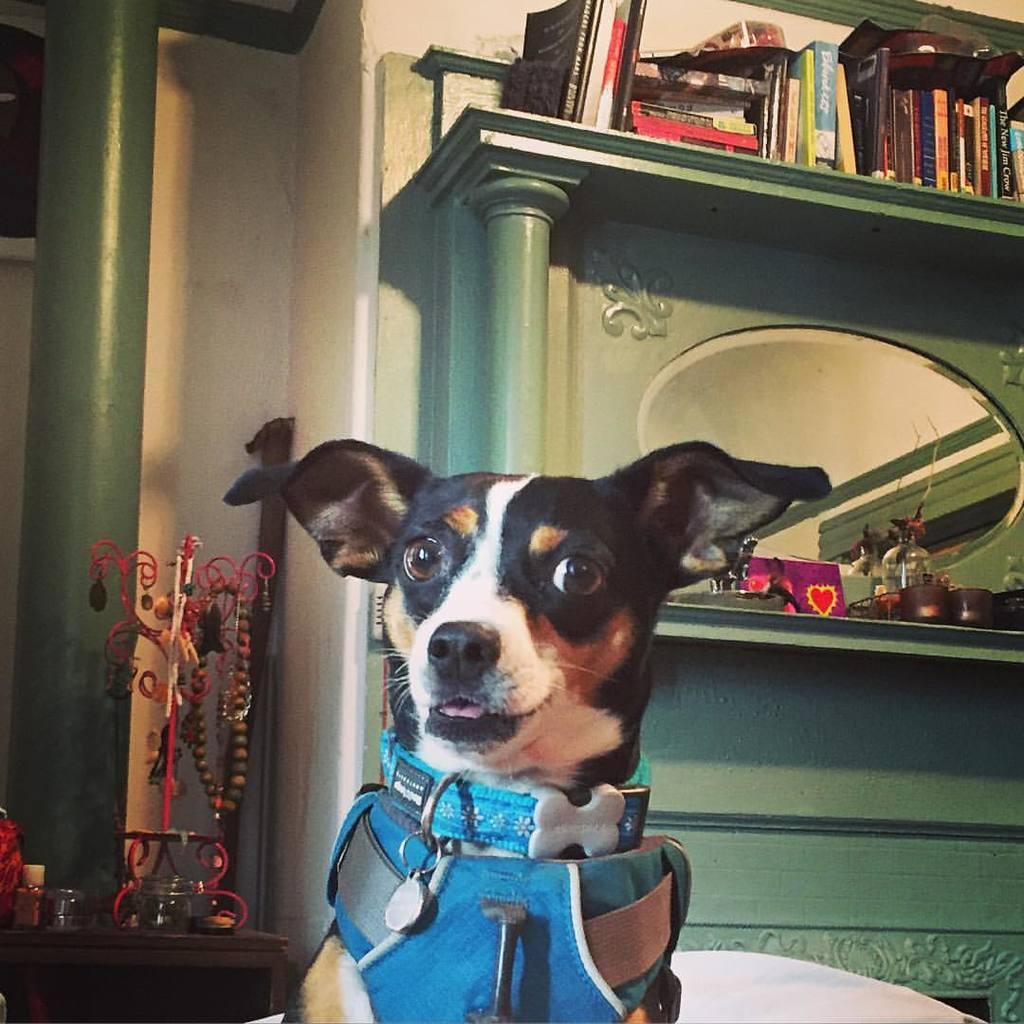Describe this image in one or two sentences. In this image there is a dog, behind the dog there are a few objects on the table and on the wooden shelf and there is a pillar. 